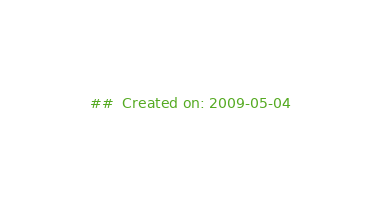<code> <loc_0><loc_0><loc_500><loc_500><_Nim_>##  Created on: 2009-05-04</code> 